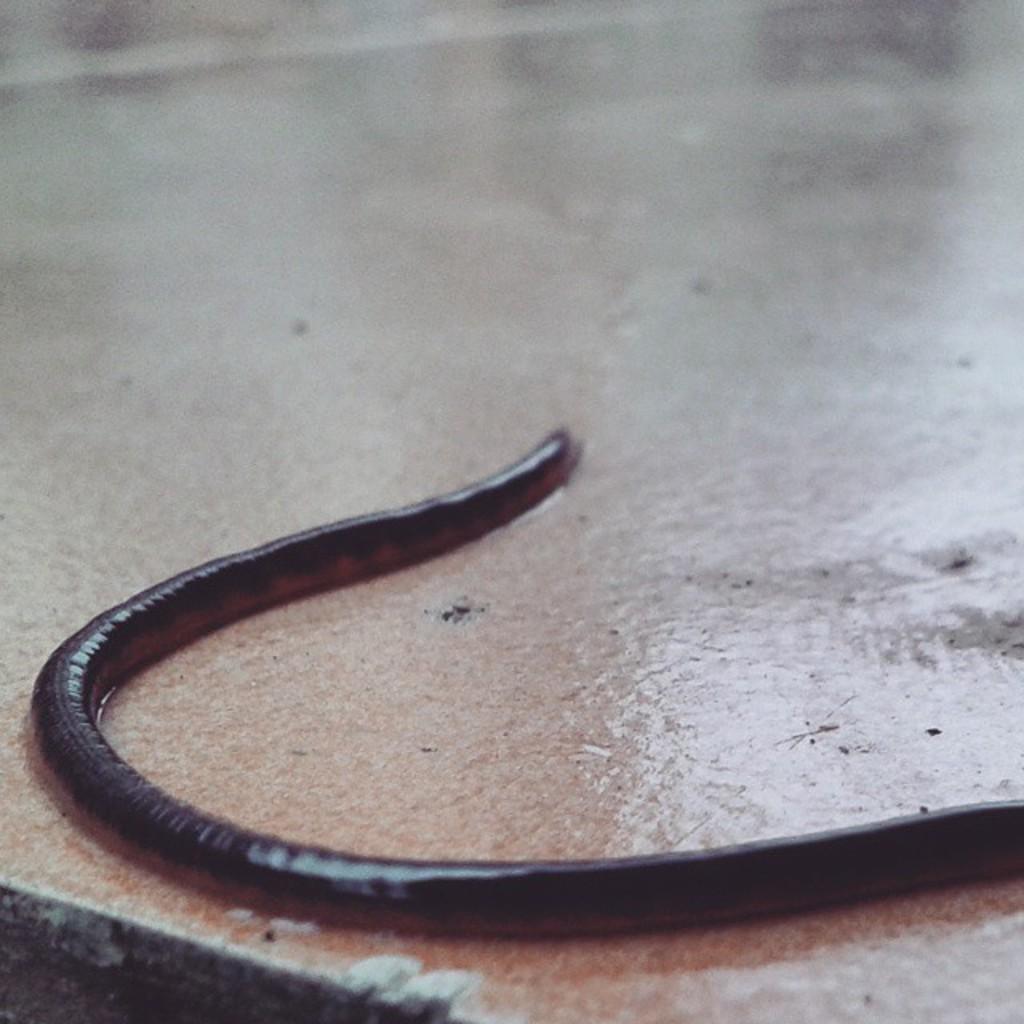Can you describe this image briefly? In this image, we can see earth warm on the path. 